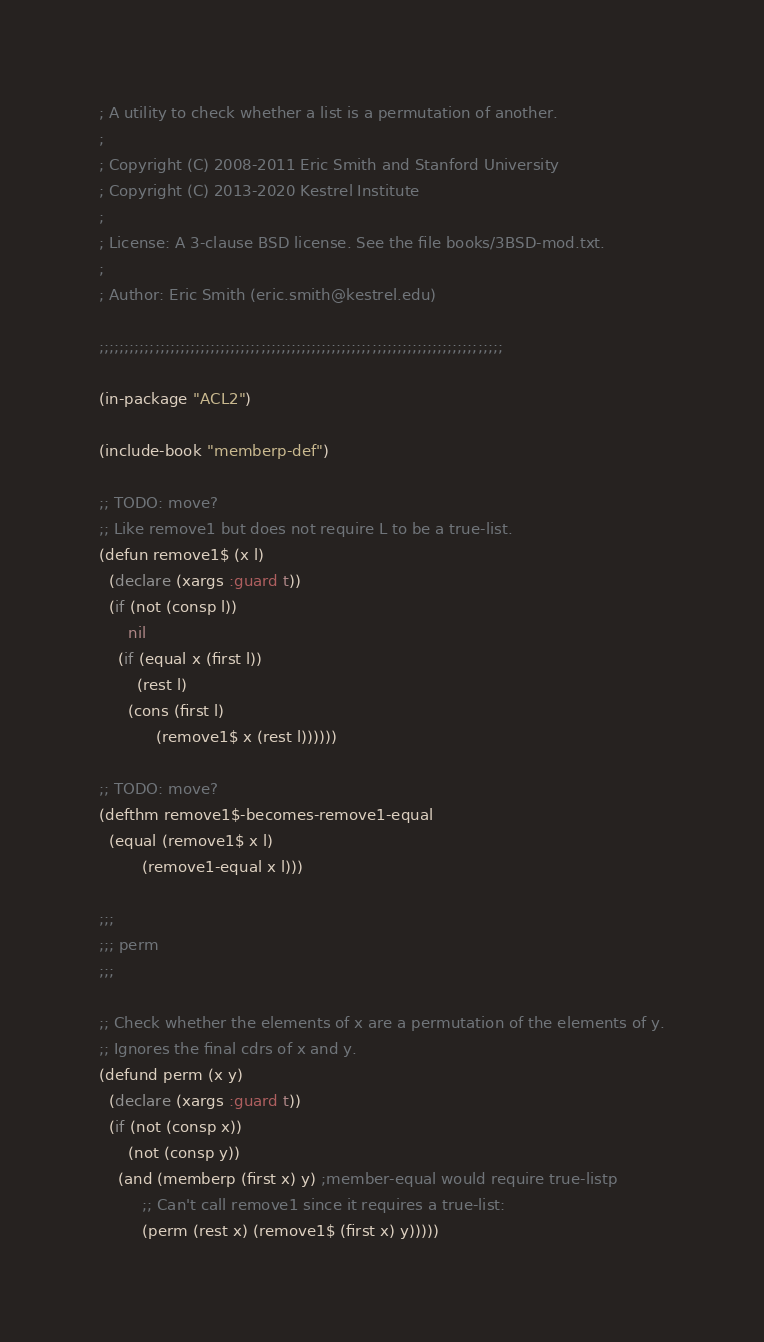Convert code to text. <code><loc_0><loc_0><loc_500><loc_500><_Lisp_>; A utility to check whether a list is a permutation of another.
;
; Copyright (C) 2008-2011 Eric Smith and Stanford University
; Copyright (C) 2013-2020 Kestrel Institute
;
; License: A 3-clause BSD license. See the file books/3BSD-mod.txt.
;
; Author: Eric Smith (eric.smith@kestrel.edu)

;;;;;;;;;;;;;;;;;;;;;;;;;;;;;;;;;;;;;;;;;;;;;;;;;;;;;;;;;;;;;;;;;;;;;;;;;;;;;;;;

(in-package "ACL2")

(include-book "memberp-def")

;; TODO: move?
;; Like remove1 but does not require L to be a true-list.
(defun remove1$ (x l)
  (declare (xargs :guard t))
  (if (not (consp l))
      nil
    (if (equal x (first l))
        (rest l)
      (cons (first l)
            (remove1$ x (rest l))))))

;; TODO: move?
(defthm remove1$-becomes-remove1-equal
  (equal (remove1$ x l)
         (remove1-equal x l)))

;;;
;;; perm
;;;

;; Check whether the elements of x are a permutation of the elements of y.
;; Ignores the final cdrs of x and y.
(defund perm (x y)
  (declare (xargs :guard t))
  (if (not (consp x))
      (not (consp y))
    (and (memberp (first x) y) ;member-equal would require true-listp
         ;; Can't call remove1 since it requires a true-list:
         (perm (rest x) (remove1$ (first x) y)))))
</code> 